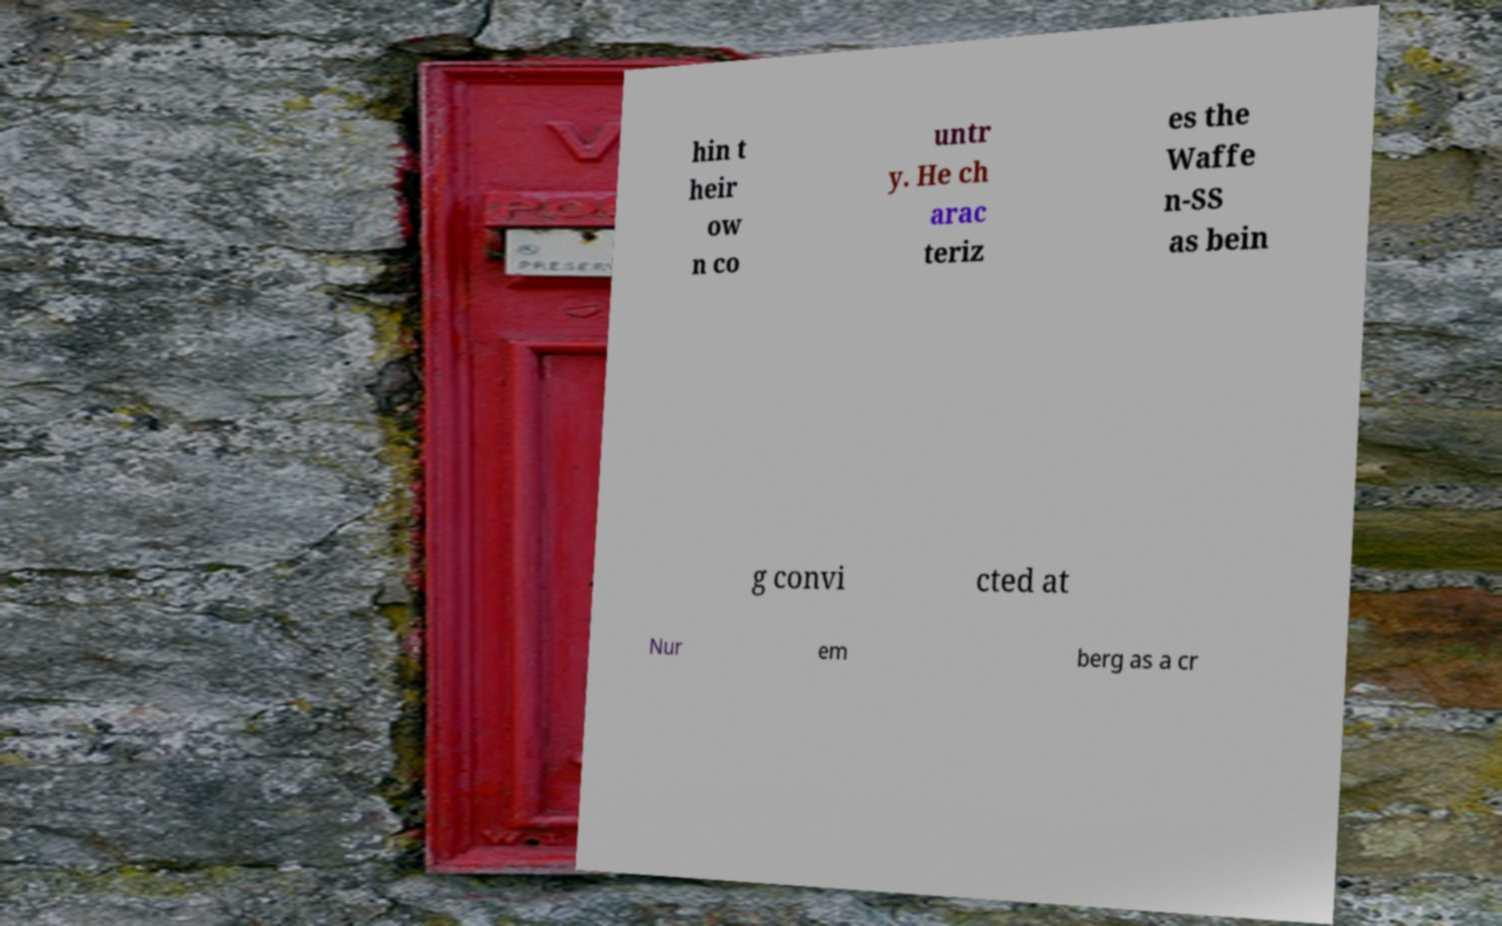Could you assist in decoding the text presented in this image and type it out clearly? hin t heir ow n co untr y. He ch arac teriz es the Waffe n-SS as bein g convi cted at Nur em berg as a cr 